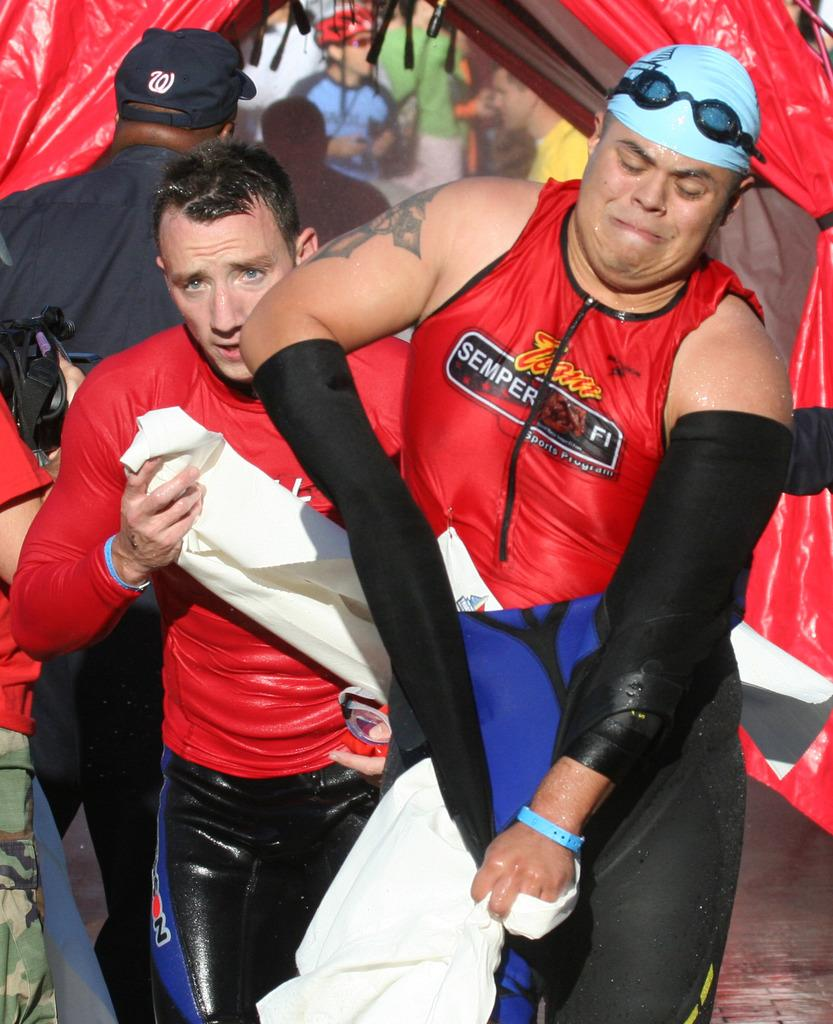<image>
Offer a succinct explanation of the picture presented. A swimmer wearing a shirt that says Team Semper Fi 